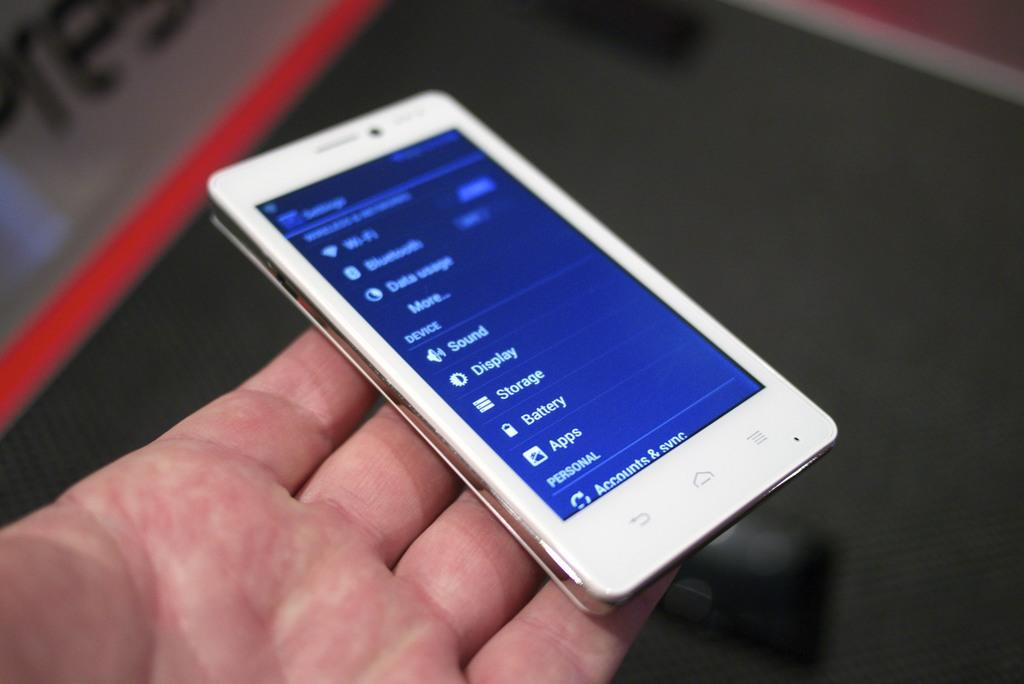<image>
Present a compact description of the photo's key features. A phone screen features options such as storage, battery and apps. 